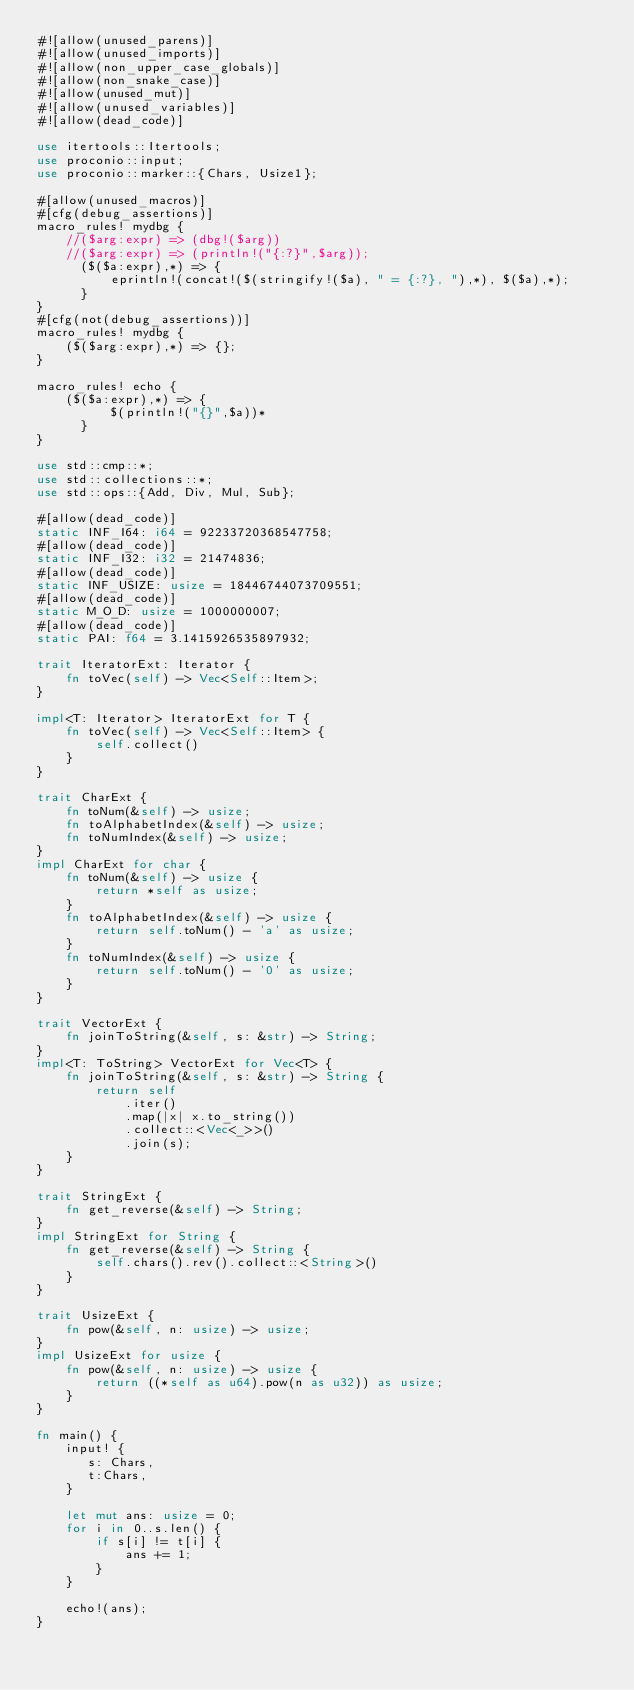<code> <loc_0><loc_0><loc_500><loc_500><_Rust_>#![allow(unused_parens)]
#![allow(unused_imports)]
#![allow(non_upper_case_globals)]
#![allow(non_snake_case)]
#![allow(unused_mut)]
#![allow(unused_variables)]
#![allow(dead_code)]

use itertools::Itertools;
use proconio::input;
use proconio::marker::{Chars, Usize1};

#[allow(unused_macros)]
#[cfg(debug_assertions)]
macro_rules! mydbg {
    //($arg:expr) => (dbg!($arg))
    //($arg:expr) => (println!("{:?}",$arg));
      ($($a:expr),*) => {
          eprintln!(concat!($(stringify!($a), " = {:?}, "),*), $($a),*);
      }
}
#[cfg(not(debug_assertions))]
macro_rules! mydbg {
    ($($arg:expr),*) => {};
}

macro_rules! echo {
    ($($a:expr),*) => {
          $(println!("{}",$a))*
      }
}

use std::cmp::*;
use std::collections::*;
use std::ops::{Add, Div, Mul, Sub};

#[allow(dead_code)]
static INF_I64: i64 = 92233720368547758;
#[allow(dead_code)]
static INF_I32: i32 = 21474836;
#[allow(dead_code)]
static INF_USIZE: usize = 18446744073709551;
#[allow(dead_code)]
static M_O_D: usize = 1000000007;
#[allow(dead_code)]
static PAI: f64 = 3.1415926535897932;

trait IteratorExt: Iterator {
    fn toVec(self) -> Vec<Self::Item>;
}

impl<T: Iterator> IteratorExt for T {
    fn toVec(self) -> Vec<Self::Item> {
        self.collect()
    }
}

trait CharExt {
    fn toNum(&self) -> usize;
    fn toAlphabetIndex(&self) -> usize;
    fn toNumIndex(&self) -> usize;
}
impl CharExt for char {
    fn toNum(&self) -> usize {
        return *self as usize;
    }
    fn toAlphabetIndex(&self) -> usize {
        return self.toNum() - 'a' as usize;
    }
    fn toNumIndex(&self) -> usize {
        return self.toNum() - '0' as usize;
    }
}

trait VectorExt {
    fn joinToString(&self, s: &str) -> String;
}
impl<T: ToString> VectorExt for Vec<T> {
    fn joinToString(&self, s: &str) -> String {
        return self
            .iter()
            .map(|x| x.to_string())
            .collect::<Vec<_>>()
            .join(s);
    }
}

trait StringExt {
    fn get_reverse(&self) -> String;
}
impl StringExt for String {
    fn get_reverse(&self) -> String {
        self.chars().rev().collect::<String>()
    }
}

trait UsizeExt {
    fn pow(&self, n: usize) -> usize;
}
impl UsizeExt for usize {
    fn pow(&self, n: usize) -> usize {
        return ((*self as u64).pow(n as u32)) as usize;
    }
}

fn main() {
    input! {
       s: Chars,
       t:Chars,
    }

    let mut ans: usize = 0;
    for i in 0..s.len() {
        if s[i] != t[i] {
            ans += 1;
        }
    }

    echo!(ans);
}
</code> 